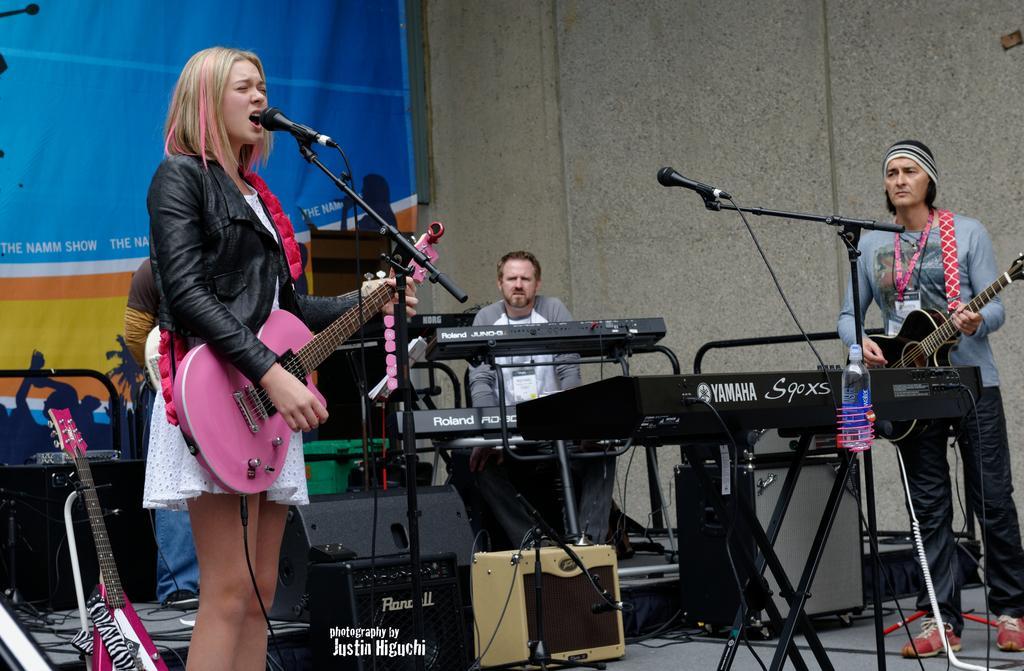Please provide a concise description of this image. In the middle of the image a man is sitting and playing a musical instrument. Bottom right side of the image a man is standing and playing a guitar. In the middle of the image there is a microphone. Bottom left side of the image a woman is standing and playing guitar and singing, Behind her there is a man. Top left side of the image there is a banner. Top right side of the image there is a wall. 